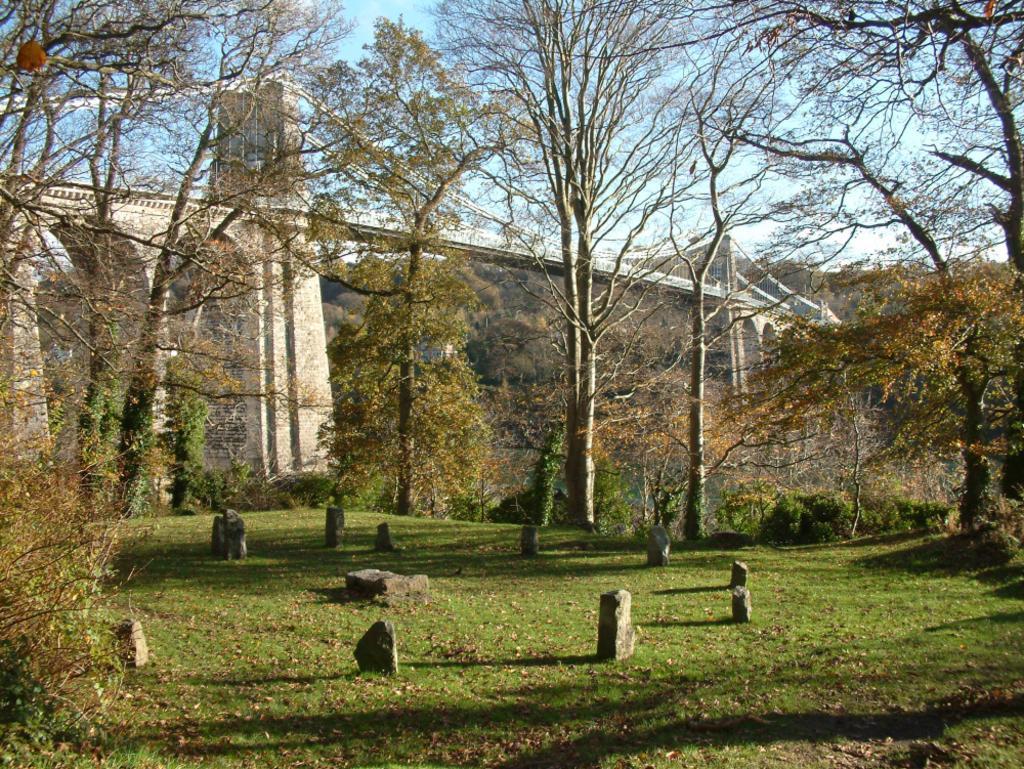Can you describe this image briefly? This picture is clicked outside. In the foreground we can see the green grass and we can see the stones. In the center we can see the plants, trees and a bridge. In the background we can see the sky and some other objects. 